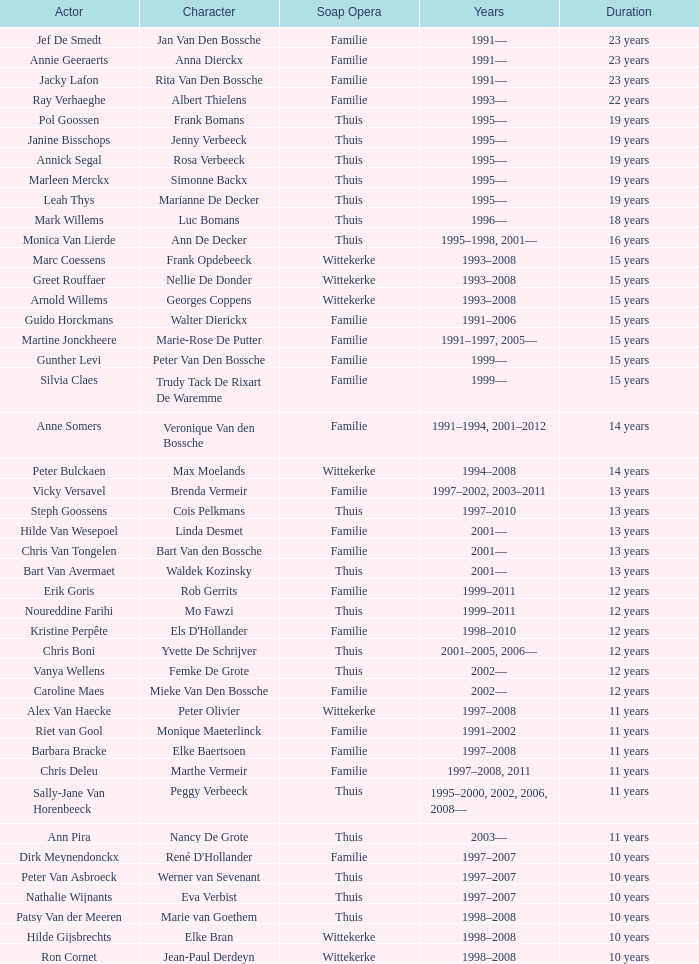What character did Vicky Versavel play for 13 years? Brenda Vermeir. 